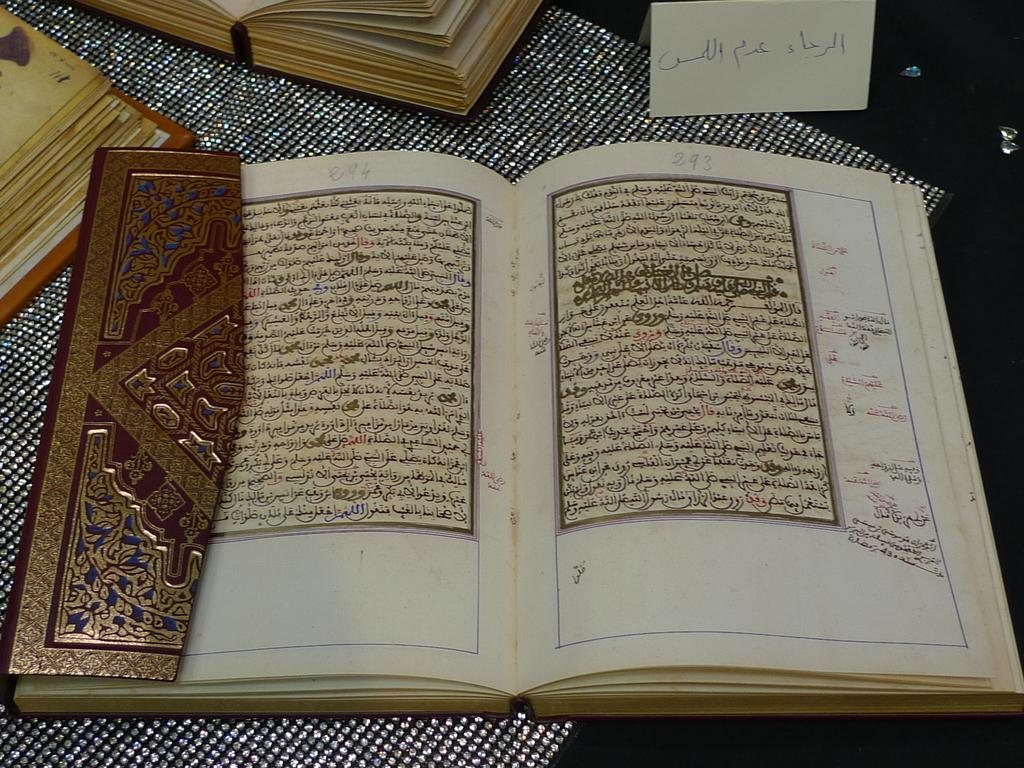How many books are opened in the image? There are three books opened in the image. What language is written in one of the books? One of the books has writing in Arabic. On what surface are the books placed? The books are placed on a silver-colored object. What else in the image has writing on it? There is a white paper with writing in the image. How does the pollution affect the insects in the image? There is no mention of pollution or insects in the image; it only features books and a white paper with writing. 